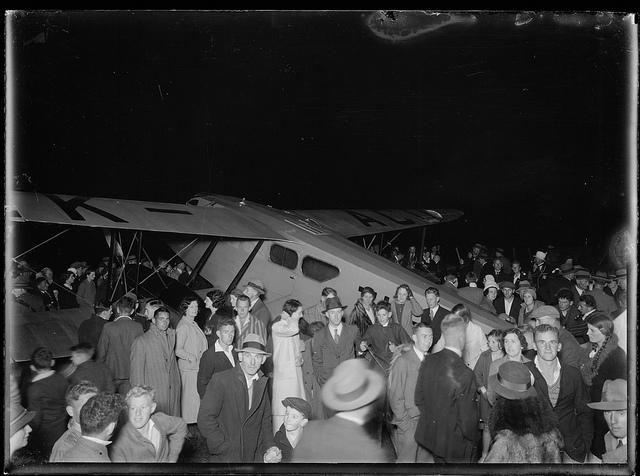Are the people on a bus?
Quick response, please. No. What time of day was the picture taken?
Give a very brief answer. Night. How old is this picture?
Give a very brief answer. Old. How many coats have pinstripes?
Be succinct. 0. What does the woman have over her arm?
Answer briefly. Purse. What is the woman on the far right holding?
Write a very short answer. Nothing. What is the guy on?
Give a very brief answer. Plane. What type of plane is that?
Short answer required. Biplane. Is it daytime?
Give a very brief answer. No. Is it nighttime?
Write a very short answer. Yes. Are the people looking at?
Answer briefly. Plane. 